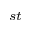<formula> <loc_0><loc_0><loc_500><loc_500>^ { s t }</formula> 